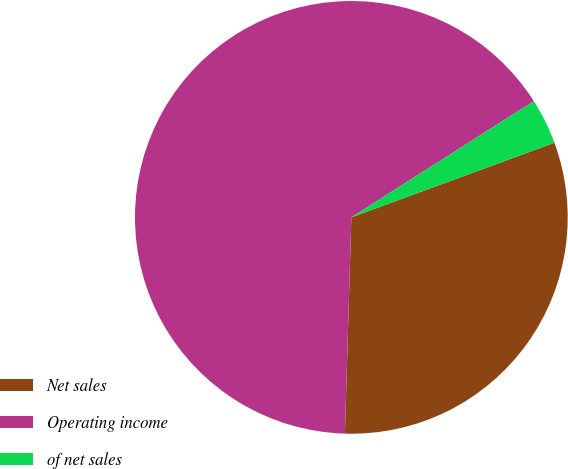Convert chart to OTSL. <chart><loc_0><loc_0><loc_500><loc_500><pie_chart><fcel>Net sales<fcel>Operating income<fcel>of net sales<nl><fcel>31.08%<fcel>65.5%<fcel>3.42%<nl></chart> 